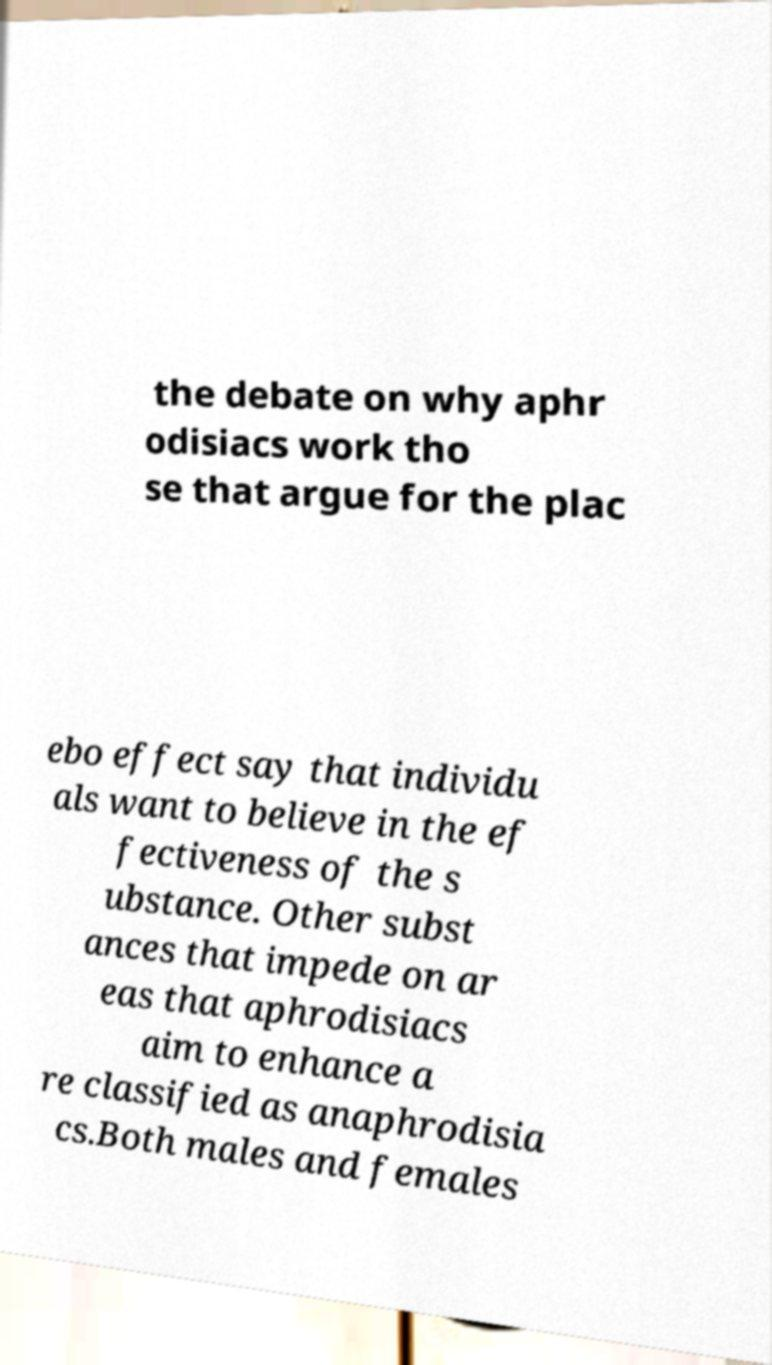Could you extract and type out the text from this image? the debate on why aphr odisiacs work tho se that argue for the plac ebo effect say that individu als want to believe in the ef fectiveness of the s ubstance. Other subst ances that impede on ar eas that aphrodisiacs aim to enhance a re classified as anaphrodisia cs.Both males and females 